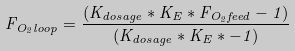<formula> <loc_0><loc_0><loc_500><loc_500>F _ { O _ { 2 } l o o p } = { \frac { ( K _ { d o s a g e } * K _ { E } * F _ { O _ { 2 } f e e d } - 1 ) } { ( K _ { d o s a g e } * K _ { E } * - 1 ) } }</formula> 